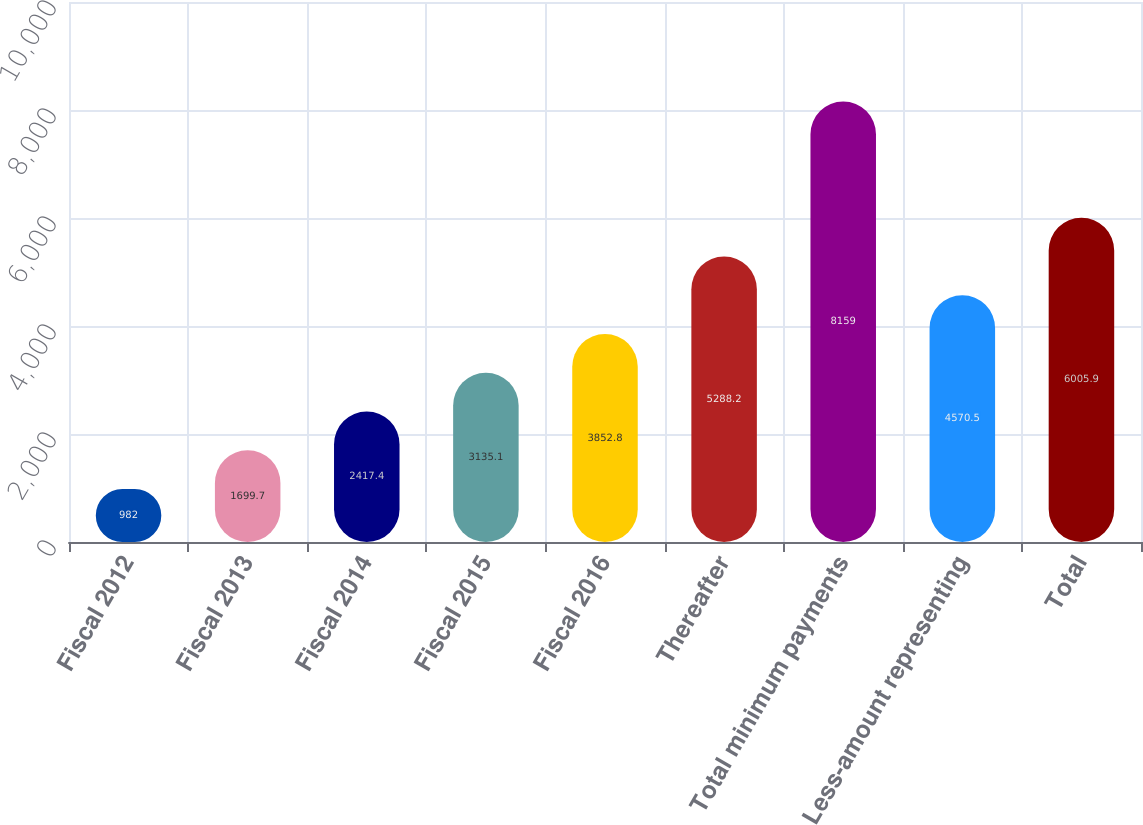Convert chart. <chart><loc_0><loc_0><loc_500><loc_500><bar_chart><fcel>Fiscal 2012<fcel>Fiscal 2013<fcel>Fiscal 2014<fcel>Fiscal 2015<fcel>Fiscal 2016<fcel>Thereafter<fcel>Total minimum payments<fcel>Less-amount representing<fcel>Total<nl><fcel>982<fcel>1699.7<fcel>2417.4<fcel>3135.1<fcel>3852.8<fcel>5288.2<fcel>8159<fcel>4570.5<fcel>6005.9<nl></chart> 